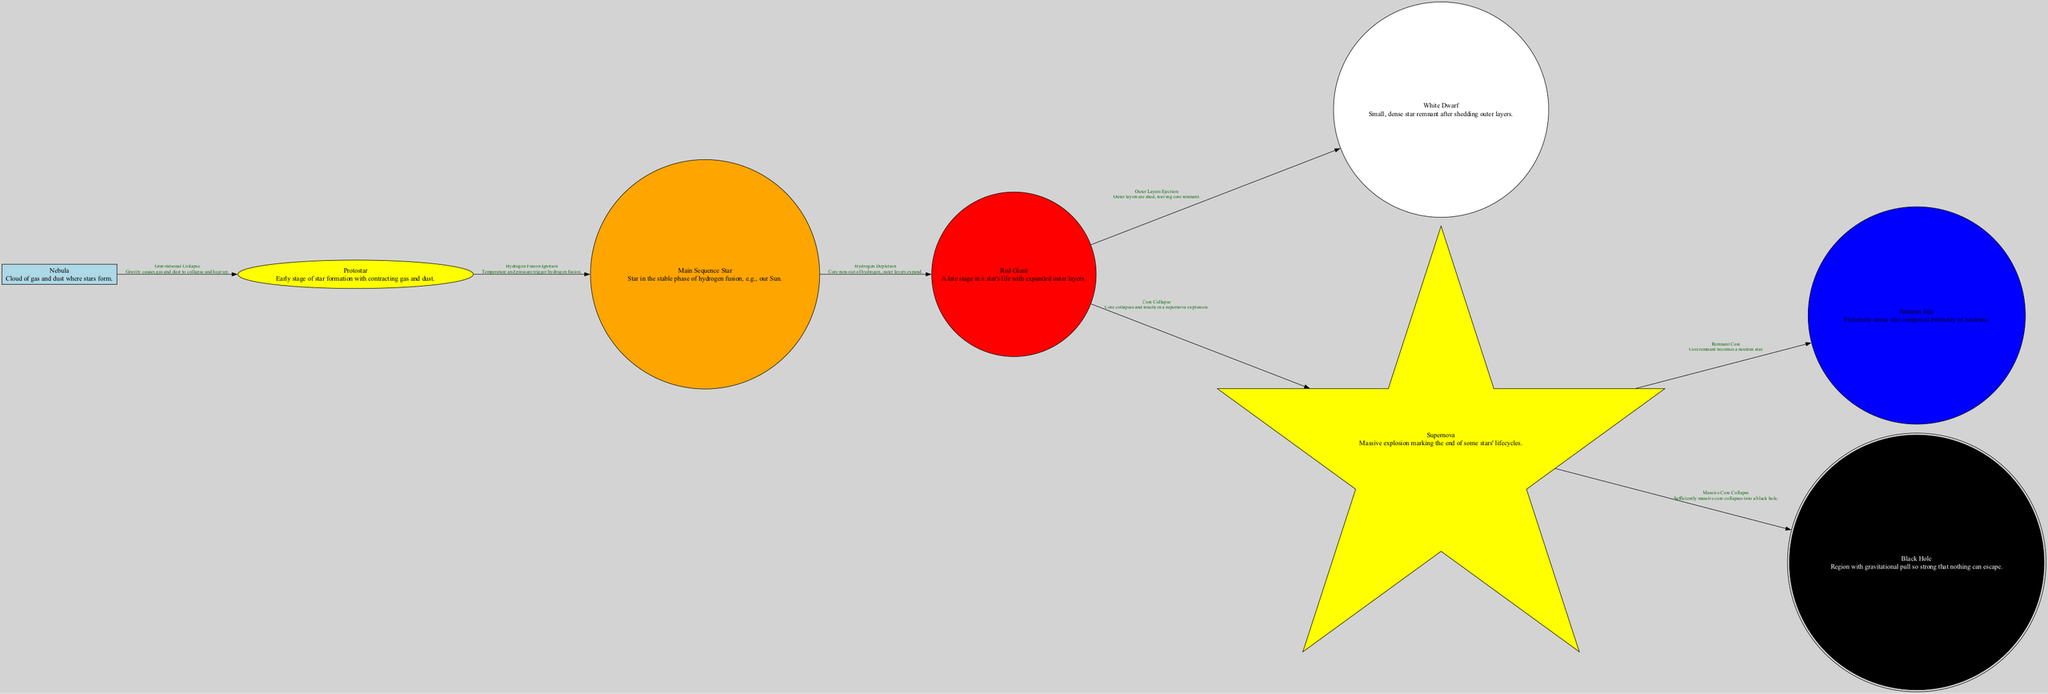What is the first stage of star formation? The first stage of star formation is represented by the "Nebula" node in the diagram, which describes a cloud of gas and dust where stars form.
Answer: Nebula How many main stages are shown in the star lifecycle? Counting the nodes in the diagram that represent main stages (Nebula, Protostar, Main Sequence Star, Red Giant, White Dwarf, Supernova, Neutron Star, Black Hole), there are eight distinct stages.
Answer: 8 What process transforms a protostar into a main sequence star? The label on the edge connecting "Protostar" to "Main Sequence Star" indicates "Hydrogen Fusion Ignition," which means this process involves the temperature and pressure triggering hydrogen fusion in the core of the protostar.
Answer: Hydrogen Fusion Ignition Which star stage is characterized by expanded outer layers? The "Red Giant" node describes a late stage in a star's life where the outer layers have expanded significantly.
Answer: Red Giant What happens to the outer layers of a red giant? The edge from "Red Giant" to "White Dwarf" indicates the process called "Outer Layers Ejection," which means that during this process, the outer layers are shed, leaving behind a dense core.
Answer: Outer Layers Ejection What is the possible remnant of a supernova? The edge leads from "Supernova" to both "Neutron Star" and "Black Hole." This indicates that depending on the mass of the remnant core, it could either become a neutron star or a black hole.
Answer: Neutron Star or Black Hole How does a red giant star end its lifecycle if it has sufficient mass? The diagram shows an edge from "Red Giant" to "Supernova," indicating that for sufficiently massive stars, the lifecycle ends with a supernova explosion due to core collapse.
Answer: Supernova What type of star follows the red giant stage for low to medium mass stars? The edge leading from "Red Giant" to "White Dwarf" shows that for low to medium mass stars, the next stage after becoming a red giant is to shed their outer layers and become a white dwarf.
Answer: White Dwarf 